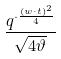<formula> <loc_0><loc_0><loc_500><loc_500>\frac { q ^ { \cdot \frac { ( w \cdot t ) ^ { 2 } } { 4 } } } { \sqrt { 4 \vartheta } }</formula> 